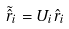Convert formula to latex. <formula><loc_0><loc_0><loc_500><loc_500>\tilde { \hat { r } } _ { i } = U _ { i } \hat { r } _ { i }</formula> 